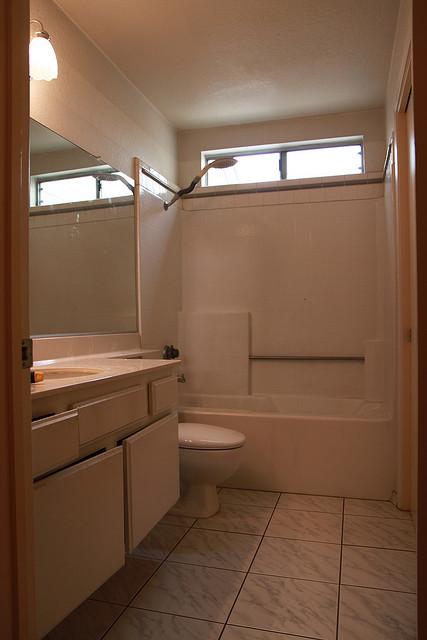Is their natural light in this room?
Give a very brief answer. Yes. What is the shower missing?
Concise answer only. Curtain. What color is the room?
Keep it brief. White. 